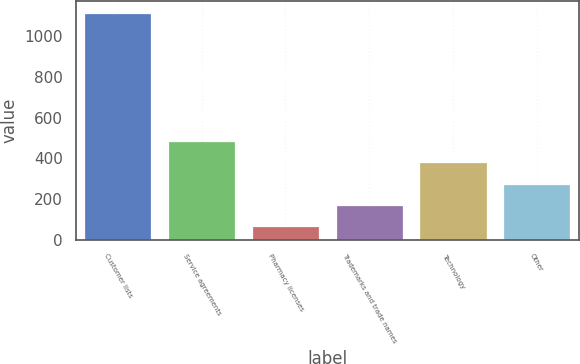Convert chart. <chart><loc_0><loc_0><loc_500><loc_500><bar_chart><fcel>Customer lists<fcel>Service agreements<fcel>Pharmacy licenses<fcel>Trademarks and trade names<fcel>Technology<fcel>Other<nl><fcel>1116<fcel>485.4<fcel>65<fcel>170.1<fcel>380.3<fcel>275.2<nl></chart> 